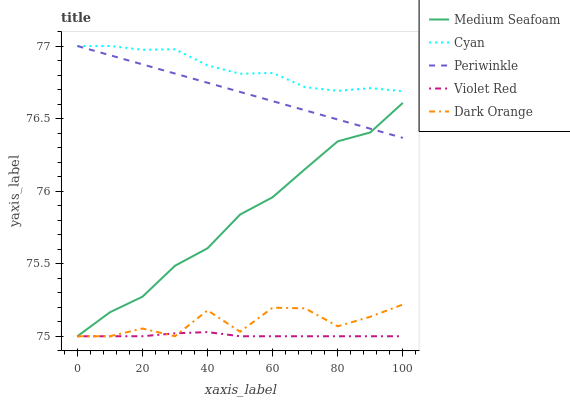Does Violet Red have the minimum area under the curve?
Answer yes or no. Yes. Does Cyan have the maximum area under the curve?
Answer yes or no. Yes. Does Periwinkle have the minimum area under the curve?
Answer yes or no. No. Does Periwinkle have the maximum area under the curve?
Answer yes or no. No. Is Periwinkle the smoothest?
Answer yes or no. Yes. Is Dark Orange the roughest?
Answer yes or no. Yes. Is Violet Red the smoothest?
Answer yes or no. No. Is Violet Red the roughest?
Answer yes or no. No. Does Violet Red have the lowest value?
Answer yes or no. Yes. Does Periwinkle have the lowest value?
Answer yes or no. No. Does Periwinkle have the highest value?
Answer yes or no. Yes. Does Violet Red have the highest value?
Answer yes or no. No. Is Violet Red less than Periwinkle?
Answer yes or no. Yes. Is Periwinkle greater than Violet Red?
Answer yes or no. Yes. Does Medium Seafoam intersect Violet Red?
Answer yes or no. Yes. Is Medium Seafoam less than Violet Red?
Answer yes or no. No. Is Medium Seafoam greater than Violet Red?
Answer yes or no. No. Does Violet Red intersect Periwinkle?
Answer yes or no. No. 